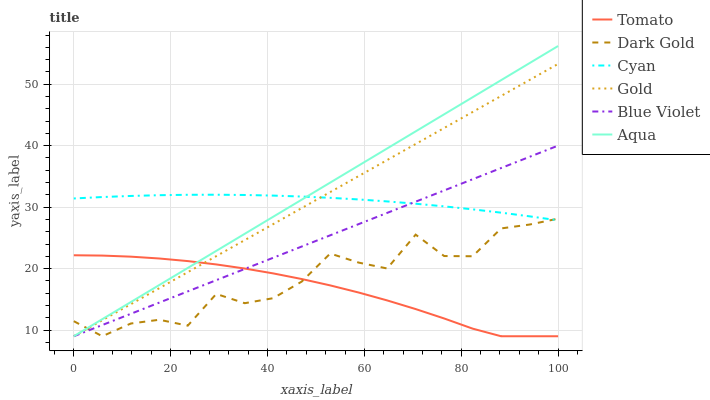Does Gold have the minimum area under the curve?
Answer yes or no. No. Does Gold have the maximum area under the curve?
Answer yes or no. No. Is Gold the smoothest?
Answer yes or no. No. Is Gold the roughest?
Answer yes or no. No. Does Cyan have the lowest value?
Answer yes or no. No. Does Gold have the highest value?
Answer yes or no. No. Is Tomato less than Cyan?
Answer yes or no. Yes. Is Cyan greater than Tomato?
Answer yes or no. Yes. Does Tomato intersect Cyan?
Answer yes or no. No. 